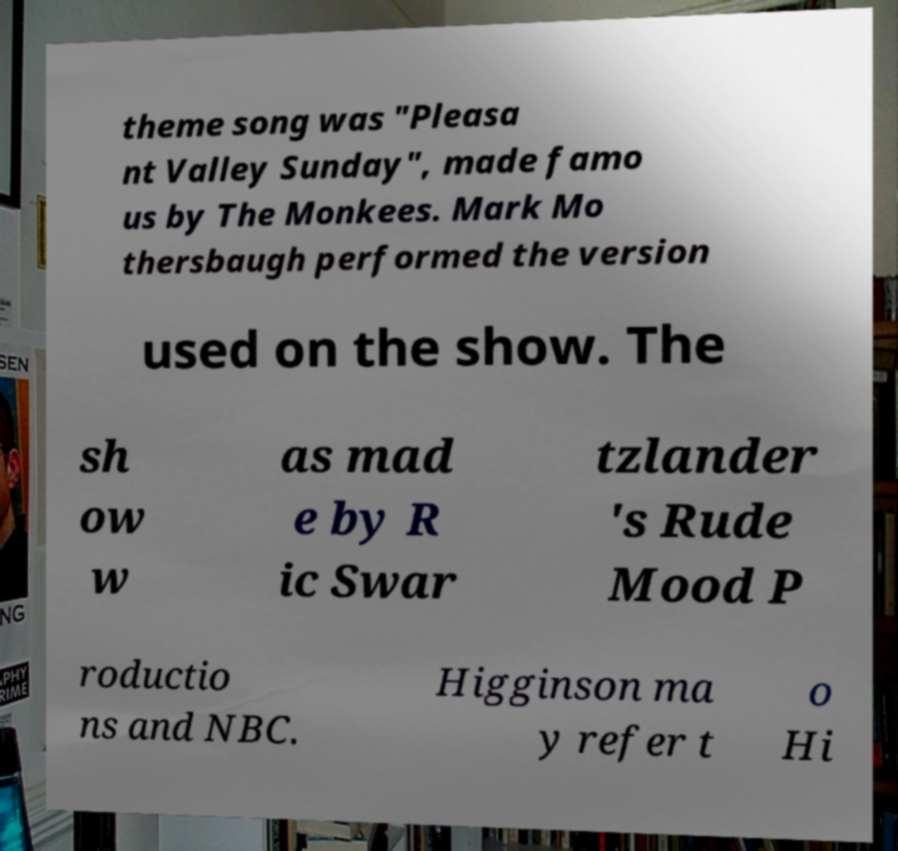What messages or text are displayed in this image? I need them in a readable, typed format. theme song was "Pleasa nt Valley Sunday", made famo us by The Monkees. Mark Mo thersbaugh performed the version used on the show. The sh ow w as mad e by R ic Swar tzlander 's Rude Mood P roductio ns and NBC. Higginson ma y refer t o Hi 